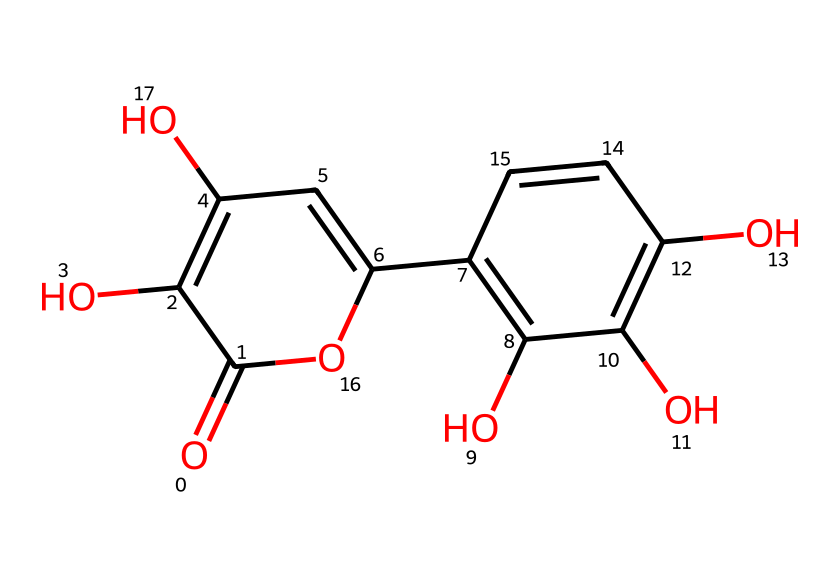What is the main functional group in quercetin? The primary functional group present in quercetin is a phenolic hydroxyl group, indicated by the -OH groups attached to the aromatic rings in its structure.
Answer: hydroxyl How many rings are present in the quercetin structure? By analyzing the SMILES, one can identify two fused aromatic rings in the structure, which are common characteristics of flavonoids.
Answer: two What is the total number of hydroxyl (-OH) groups in quercetin? Counting the -OH groups visible in the structural representation reveals that there are five hydroxyl groups attached to the aromatic rings.
Answer: five Which element is most abundant in quercetin's chemical structure? In examining the structure, carbon atoms (C) are present in the majority, forming the backbone of the flavonoid’s aromatic rings and other parts.
Answer: carbon Does quercetin have any carbonyl (C=O) groups? The presence of a carbonyl group in a chemical can be identified by its C=O structure, and in quercetin, there is only one such group located within its structure.
Answer: one Is quercetin considered a strong antioxidant? The presence of multiple hydroxyl groups contributes to quercetin's ability to donate hydrogen atoms and scavenge free radicals, thereby confirming its status as a potent antioxidant.
Answer: yes 